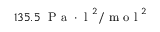<formula> <loc_0><loc_0><loc_500><loc_500>1 3 5 . 5 \, P a \cdot l ^ { 2 } / m o l ^ { 2 }</formula> 